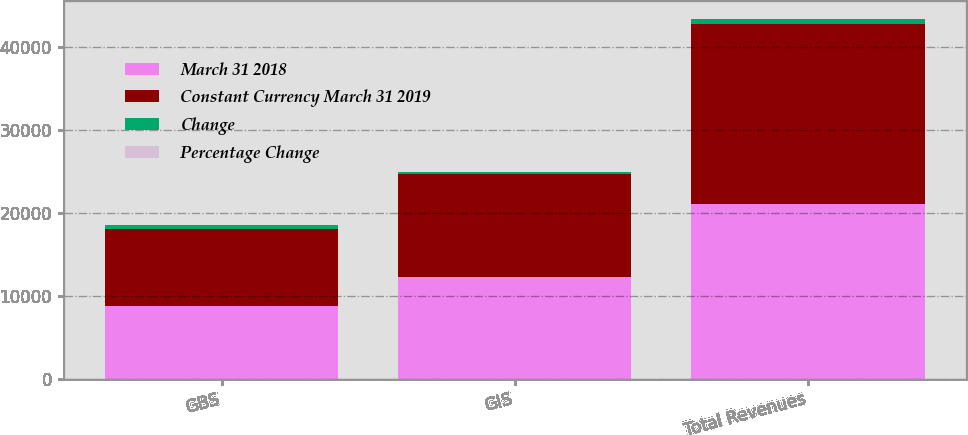Convert chart. <chart><loc_0><loc_0><loc_500><loc_500><stacked_bar_chart><ecel><fcel>GBS<fcel>GIS<fcel>Total Revenues<nl><fcel>March 31 2018<fcel>8823<fcel>12282<fcel>21105<nl><fcel>Constant Currency March 31 2019<fcel>9254<fcel>12479<fcel>21733<nl><fcel>Change<fcel>431<fcel>197<fcel>628<nl><fcel>Percentage Change<fcel>4.7<fcel>1.6<fcel>2.9<nl></chart> 